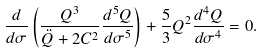Convert formula to latex. <formula><loc_0><loc_0><loc_500><loc_500>\frac { d } { d \sigma } \left ( \frac { Q ^ { 3 } } { \ddot { Q } + 2 C ^ { 2 } } \frac { d ^ { 5 } Q } { d \sigma ^ { 5 } } \right ) + \frac { 5 } { 3 } Q ^ { 2 } \frac { d ^ { 4 } Q } { d \sigma ^ { 4 } } = 0 .</formula> 